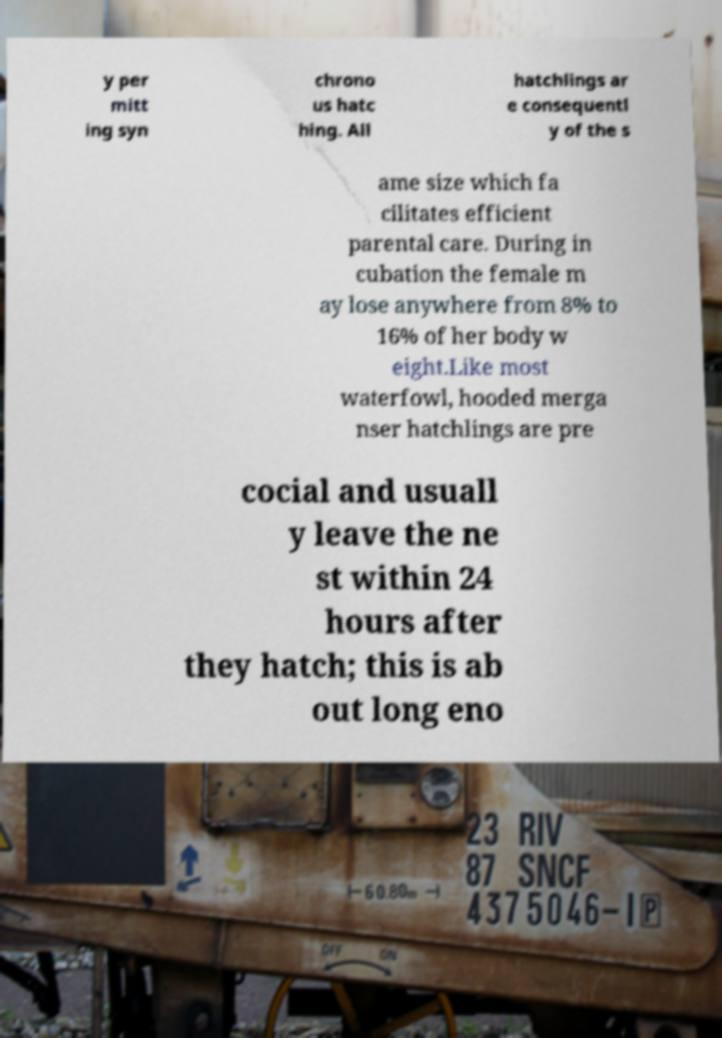Could you assist in decoding the text presented in this image and type it out clearly? y per mitt ing syn chrono us hatc hing. All hatchlings ar e consequentl y of the s ame size which fa cilitates efficient parental care. During in cubation the female m ay lose anywhere from 8% to 16% of her body w eight.Like most waterfowl, hooded merga nser hatchlings are pre cocial and usuall y leave the ne st within 24 hours after they hatch; this is ab out long eno 